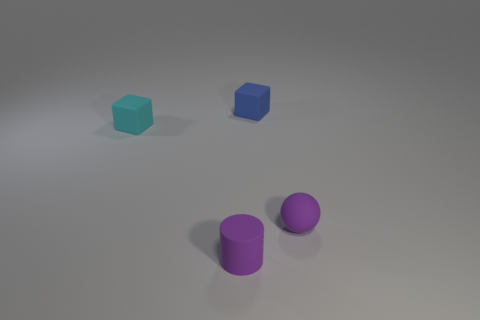Are there any tiny purple things that have the same shape as the cyan thing?
Make the answer very short. No. The other rubber cube that is the same size as the cyan matte cube is what color?
Ensure brevity in your answer.  Blue. What number of objects are either tiny matte cubes that are to the right of the tiny cyan matte cube or objects in front of the small cyan matte thing?
Give a very brief answer. 3. How many things are purple spheres or small blue objects?
Provide a short and direct response. 2. How big is the matte object that is both behind the purple sphere and in front of the blue thing?
Give a very brief answer. Small. What number of small cubes are made of the same material as the cyan thing?
Your response must be concise. 1. What color is the sphere that is made of the same material as the blue thing?
Provide a succinct answer. Purple. There is a matte object to the left of the purple rubber cylinder; does it have the same color as the cylinder?
Keep it short and to the point. No. What is the material of the cube behind the small cyan cube?
Keep it short and to the point. Rubber. Are there an equal number of tiny rubber balls that are behind the tiny purple cylinder and purple things?
Ensure brevity in your answer.  No. 